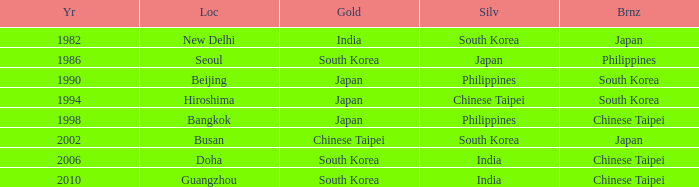Which Bronze has a Year smaller than 1994, and a Silver of south korea? Japan. 